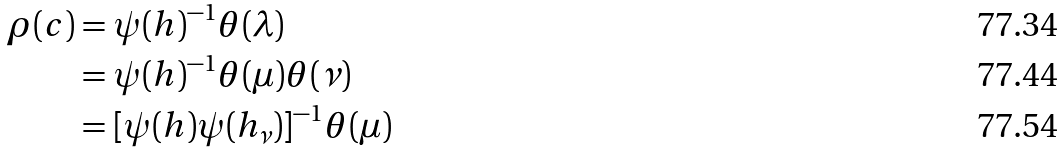Convert formula to latex. <formula><loc_0><loc_0><loc_500><loc_500>\rho ( c ) & = \psi ( h ) ^ { - 1 } \theta ( \lambda ) \\ & = \psi ( h ) ^ { - 1 } \theta ( \mu ) \theta ( \nu ) \\ & = [ \psi ( h ) \psi ( h _ { \nu } ) ] ^ { - 1 } \theta ( \mu )</formula> 